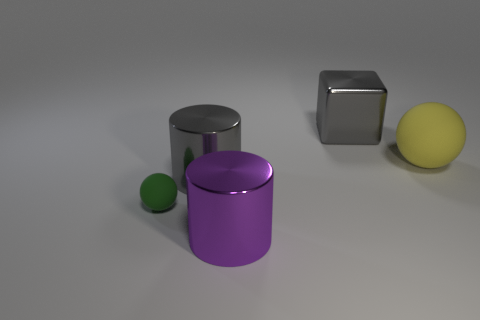Is there a object of the same color as the metal cube?
Keep it short and to the point. Yes. What is the size of the shiny cylinder that is the same color as the large block?
Give a very brief answer. Large. There is a gray metallic cylinder; is its size the same as the sphere that is left of the big matte sphere?
Make the answer very short. No. What number of other things are the same color as the small ball?
Your answer should be compact. 0. There is a big yellow rubber sphere; are there any large purple cylinders right of it?
Your response must be concise. No. How many objects are either tiny green metallic cubes or large gray metallic objects that are right of the large purple cylinder?
Your answer should be compact. 1. Are there any large objects that are in front of the cylinder behind the tiny sphere?
Your answer should be compact. Yes. What shape is the thing behind the large object to the right of the large cube on the right side of the tiny green rubber thing?
Your response must be concise. Cube. What color is the object that is both right of the small rubber ball and in front of the gray cylinder?
Provide a short and direct response. Purple. The large gray metallic object that is right of the big purple thing has what shape?
Provide a short and direct response. Cube. 